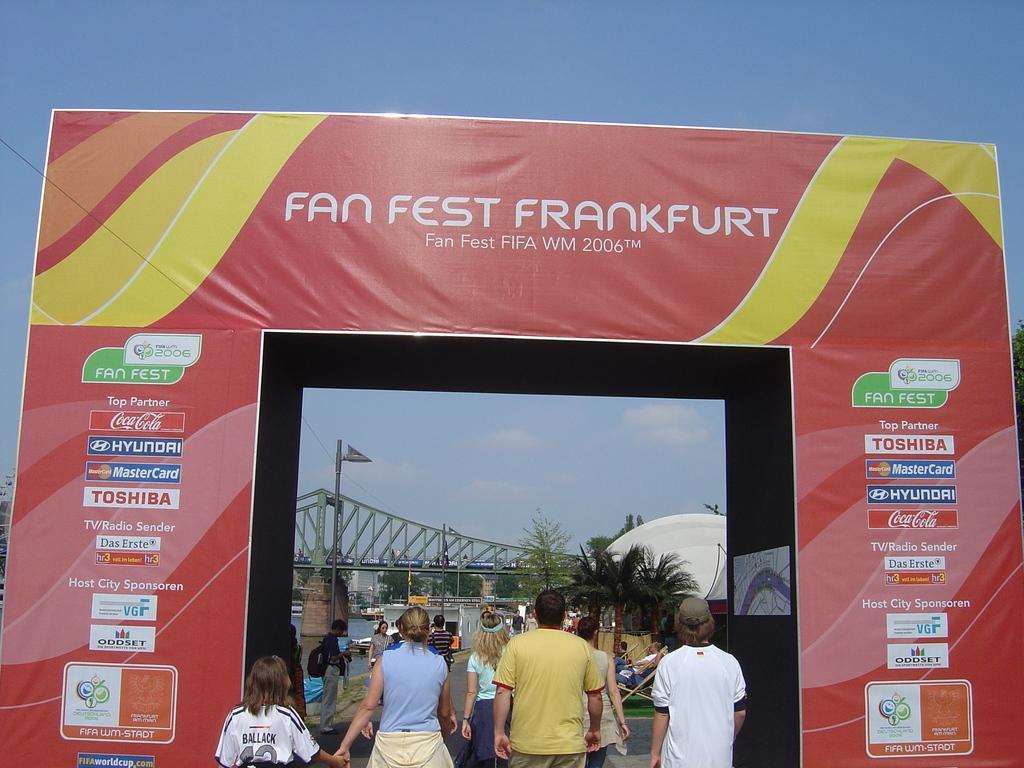Describe this image in one or two sentences. In this image, we can see a hoarding where there are some people who are entering through it and there is also a bridge and also some water which is present under the bridge. 